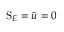Convert formula to latex. <formula><loc_0><loc_0><loc_500><loc_500>S _ { E } = \bar { u } = 0</formula> 